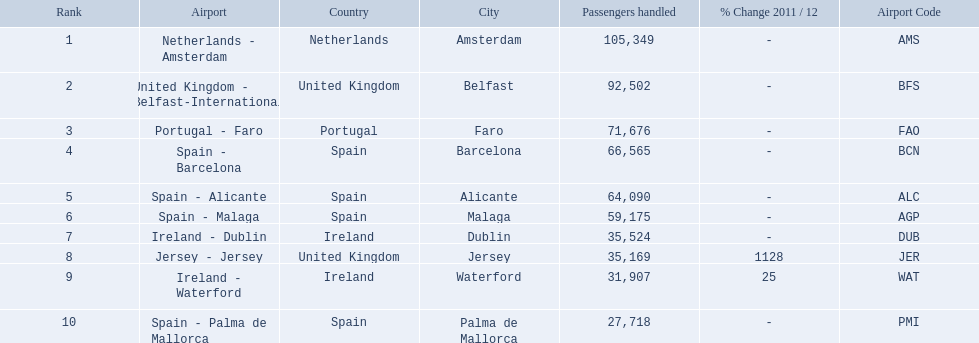What are all the airports in the top 10 busiest routes to and from london southend airport? Netherlands - Amsterdam, United Kingdom - Belfast-International, Portugal - Faro, Spain - Barcelona, Spain - Alicante, Spain - Malaga, Ireland - Dublin, Jersey - Jersey, Ireland - Waterford, Spain - Palma de Mallorca. Which airports are in portugal? Portugal - Faro. 